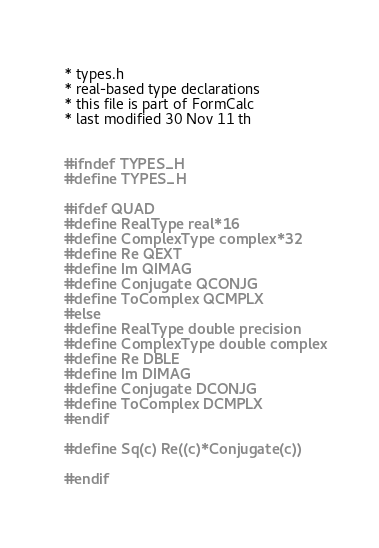Convert code to text. <code><loc_0><loc_0><loc_500><loc_500><_C_>* types.h
* real-based type declarations
* this file is part of FormCalc
* last modified 30 Nov 11 th


#ifndef TYPES_H
#define TYPES_H

#ifdef QUAD
#define RealType real*16
#define ComplexType complex*32
#define Re QEXT
#define Im QIMAG
#define Conjugate QCONJG
#define ToComplex QCMPLX
#else
#define RealType double precision
#define ComplexType double complex
#define Re DBLE
#define Im DIMAG
#define Conjugate DCONJG
#define ToComplex DCMPLX
#endif

#define Sq(c) Re((c)*Conjugate(c))

#endif

</code> 